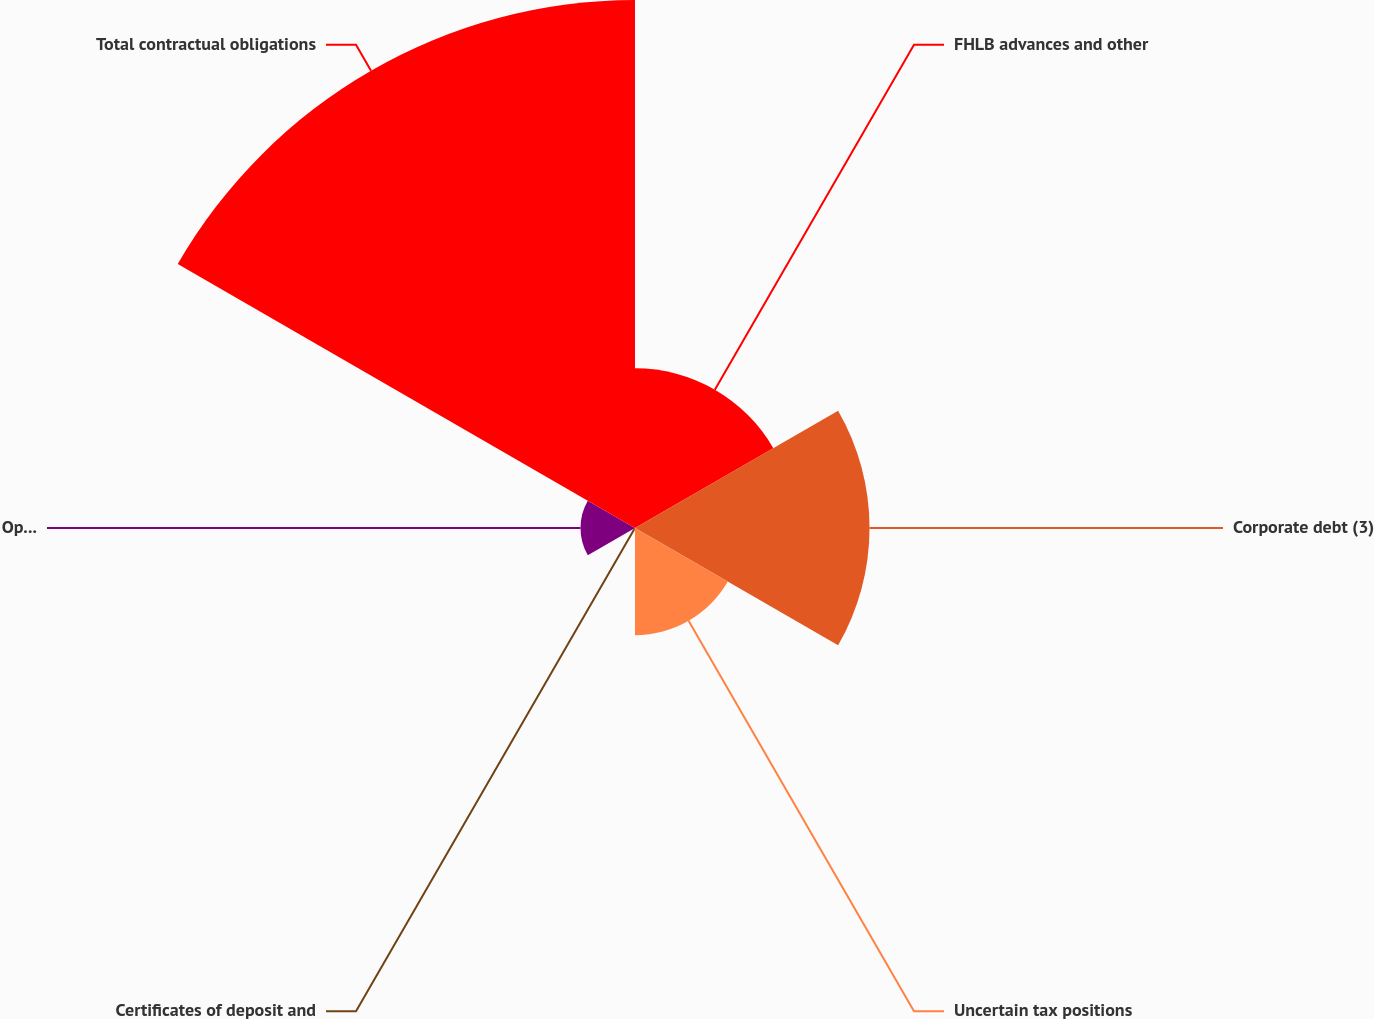<chart> <loc_0><loc_0><loc_500><loc_500><pie_chart><fcel>FHLB advances and other<fcel>Corporate debt (3)<fcel>Uncertain tax positions<fcel>Certificates of deposit and<fcel>Operating lease payments (5)<fcel>Total contractual obligations<nl><fcel>14.71%<fcel>21.6%<fcel>9.87%<fcel>0.17%<fcel>5.02%<fcel>48.63%<nl></chart> 